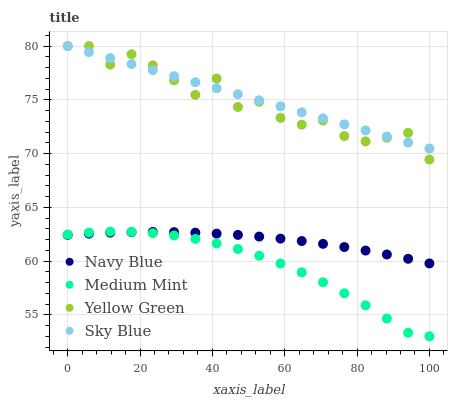Does Medium Mint have the minimum area under the curve?
Answer yes or no. Yes. Does Sky Blue have the maximum area under the curve?
Answer yes or no. Yes. Does Navy Blue have the minimum area under the curve?
Answer yes or no. No. Does Navy Blue have the maximum area under the curve?
Answer yes or no. No. Is Sky Blue the smoothest?
Answer yes or no. Yes. Is Yellow Green the roughest?
Answer yes or no. Yes. Is Navy Blue the smoothest?
Answer yes or no. No. Is Navy Blue the roughest?
Answer yes or no. No. Does Medium Mint have the lowest value?
Answer yes or no. Yes. Does Navy Blue have the lowest value?
Answer yes or no. No. Does Sky Blue have the highest value?
Answer yes or no. Yes. Does Navy Blue have the highest value?
Answer yes or no. No. Is Medium Mint less than Yellow Green?
Answer yes or no. Yes. Is Yellow Green greater than Navy Blue?
Answer yes or no. Yes. Does Sky Blue intersect Yellow Green?
Answer yes or no. Yes. Is Sky Blue less than Yellow Green?
Answer yes or no. No. Is Sky Blue greater than Yellow Green?
Answer yes or no. No. Does Medium Mint intersect Yellow Green?
Answer yes or no. No. 